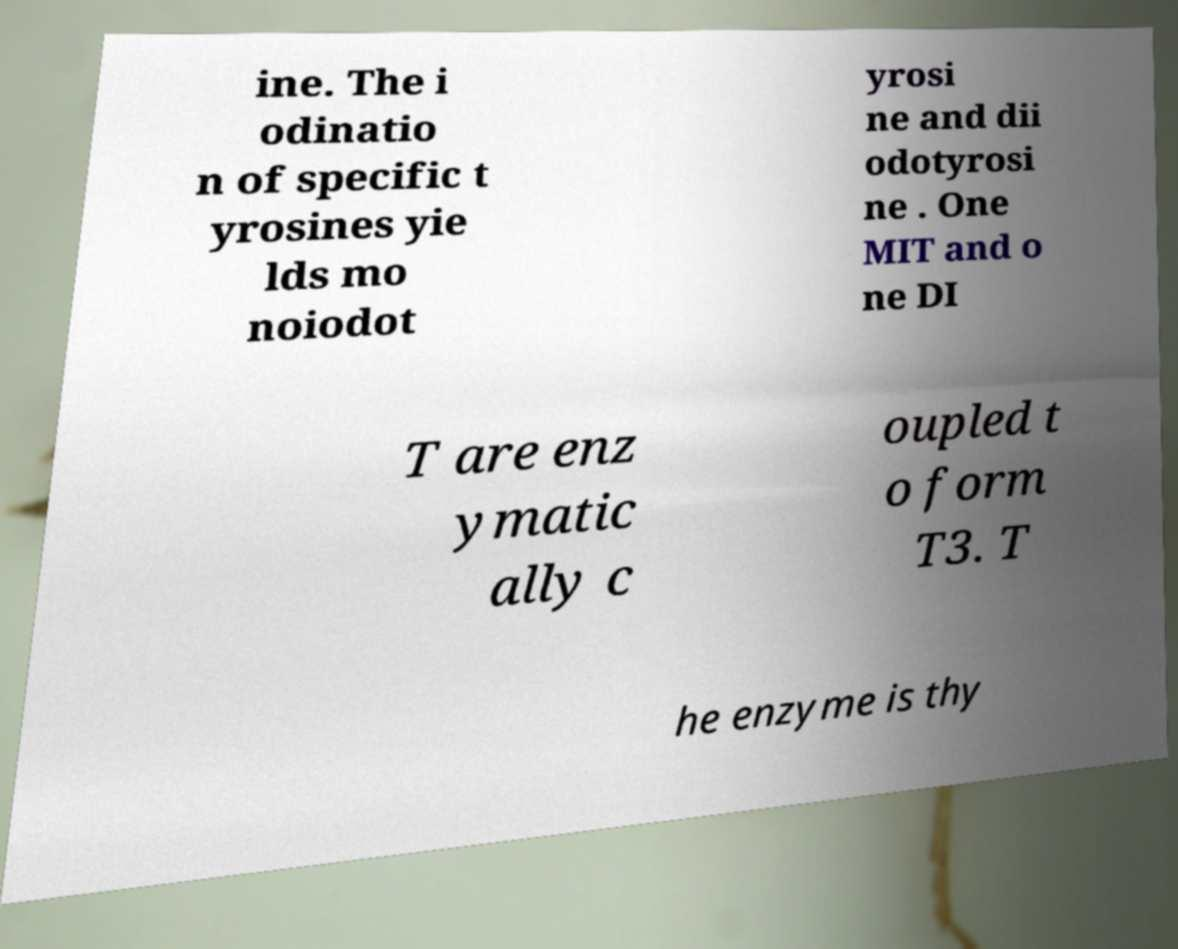I need the written content from this picture converted into text. Can you do that? ine. The i odinatio n of specific t yrosines yie lds mo noiodot yrosi ne and dii odotyrosi ne . One MIT and o ne DI T are enz ymatic ally c oupled t o form T3. T he enzyme is thy 